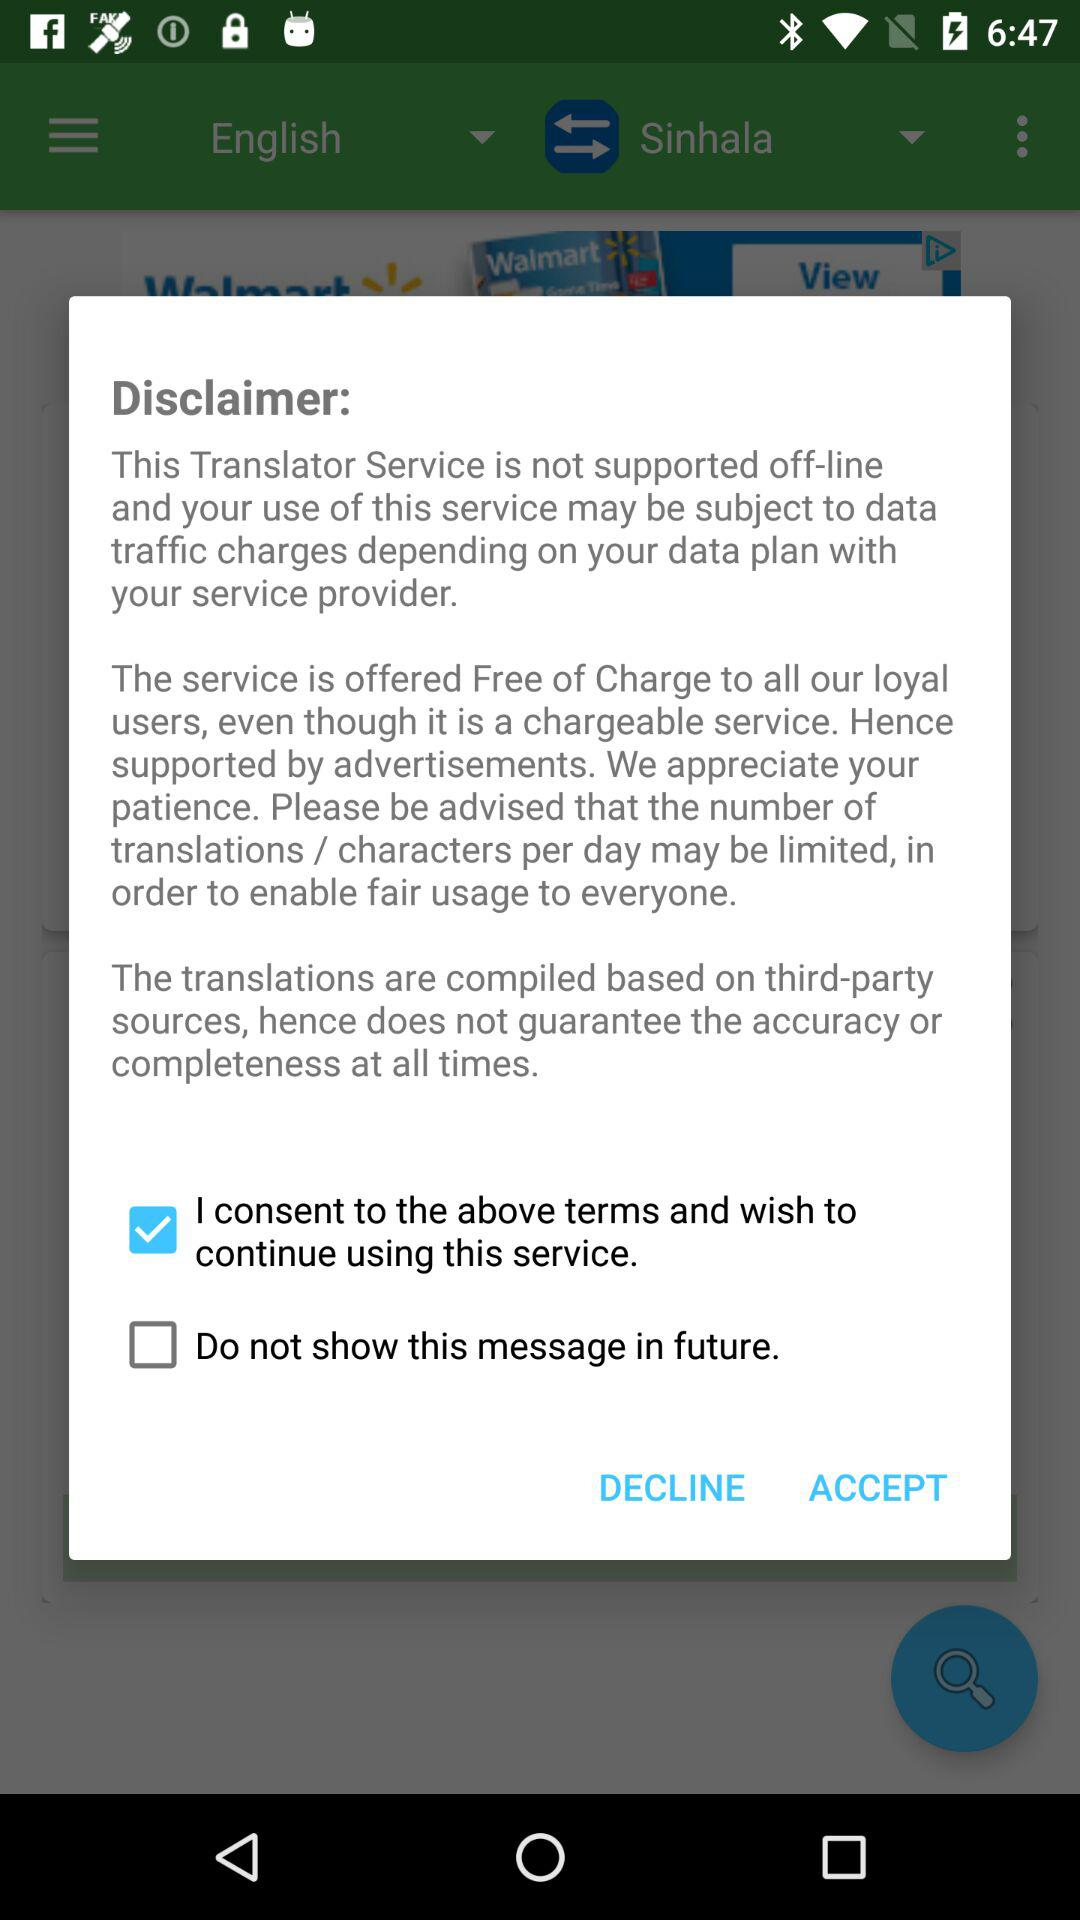Who is the third-party service that sources the translations?
When the provided information is insufficient, respond with <no answer>. <no answer> 